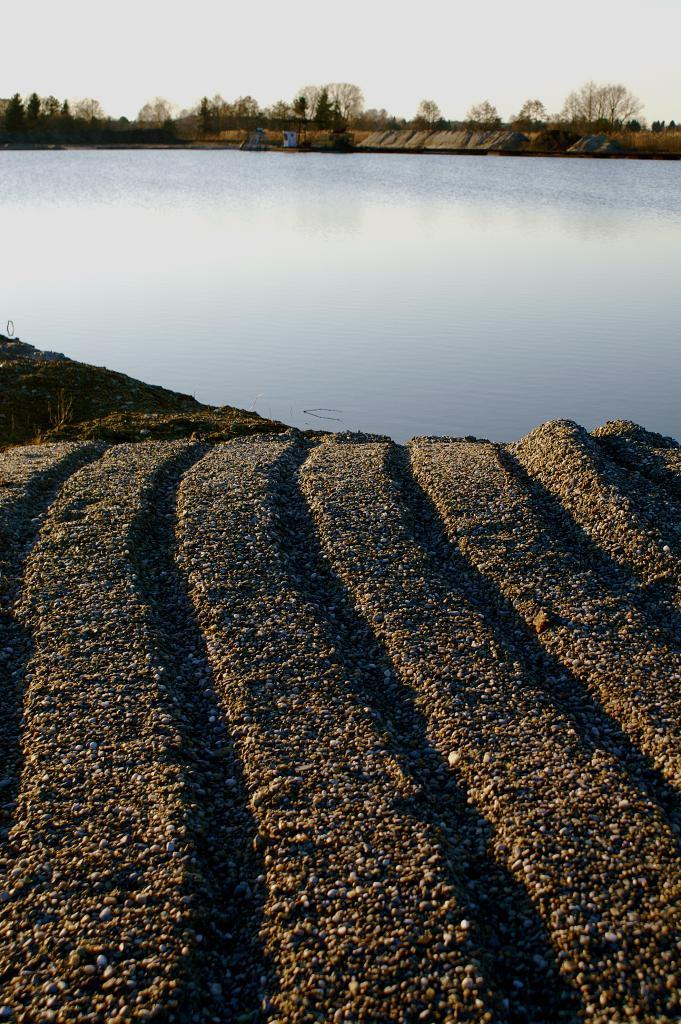What type of natural environment is depicted in the image? The image contains water, sand, and trees, which suggests a beach or coastal setting. What can be seen in the sky in the image? The sky is visible in the image. What is the primary substance underfoot in the image? There is sand in the image. What type of stew is being prepared on the beach in the image? There is no stew or cooking activity depicted in the image; it features a natural environment with water, sand, trees, and the sky. 